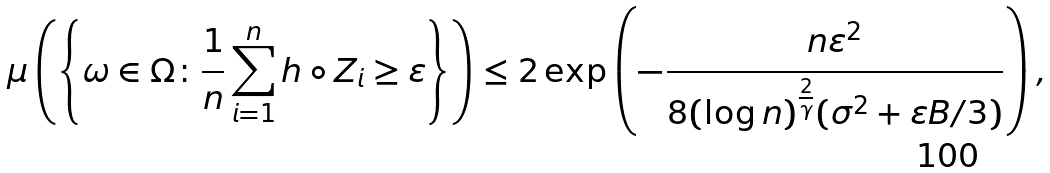<formula> <loc_0><loc_0><loc_500><loc_500>\mu \left ( \left \{ \omega \in \Omega \colon \frac { 1 } { n } \sum _ { i = 1 } ^ { n } h \circ Z _ { i } \geq \varepsilon \right \} \right ) \leq 2 \exp \left ( - \frac { n \varepsilon ^ { 2 } } { 8 ( \log n ) ^ { \frac { 2 } { \gamma } } ( \sigma ^ { 2 } + \varepsilon B / 3 ) } \right ) ,</formula> 